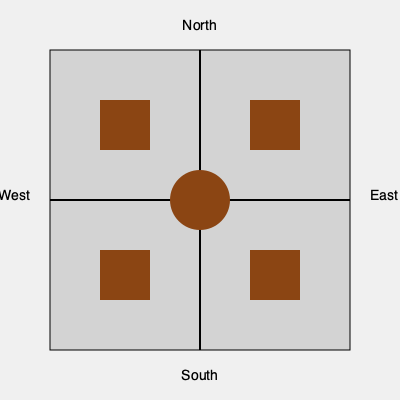Based on Dr. Warwick's history walks, which of the following structures in the aerial view of Burley's historic town center corresponds to the Old Town Hall? 1. The image shows an aerial view of Burley's historic town center.
2. The center of the image contains a circular structure, likely representing the central square or a roundabout.
3. There are four rectangular structures in each corner of the image, equidistant from the center.
4. During Dr. Warwick's history walks, it was often mentioned that the Old Town Hall was the most prominent building in the town center.
5. Historically, town halls were typically placed in central locations for easy access by citizens.
6. Given this information, the circular structure in the center is the most likely candidate for the Old Town Hall.
7. The other rectangular structures probably represent other important buildings or blocks in the historic town center.
Answer: The circular structure in the center 